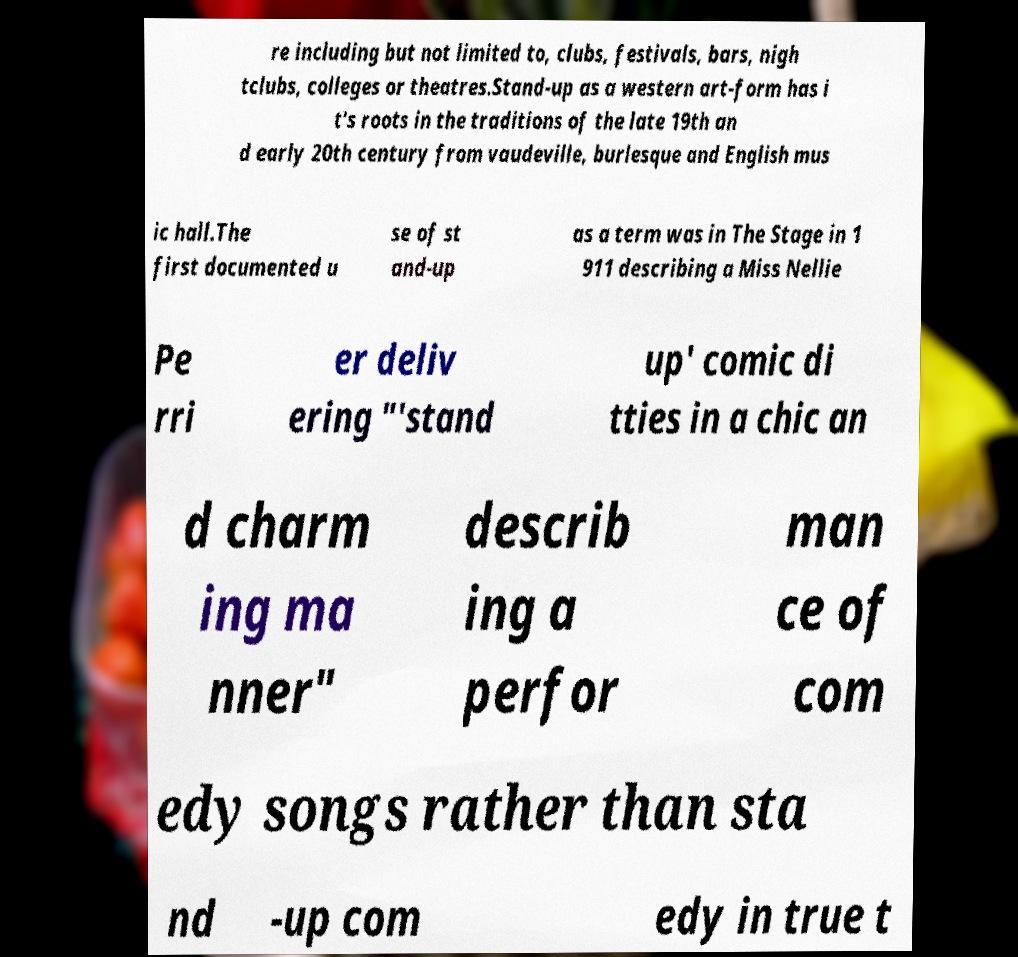Could you extract and type out the text from this image? re including but not limited to, clubs, festivals, bars, nigh tclubs, colleges or theatres.Stand-up as a western art-form has i t's roots in the traditions of the late 19th an d early 20th century from vaudeville, burlesque and English mus ic hall.The first documented u se of st and-up as a term was in The Stage in 1 911 describing a Miss Nellie Pe rri er deliv ering "'stand up' comic di tties in a chic an d charm ing ma nner" describ ing a perfor man ce of com edy songs rather than sta nd -up com edy in true t 